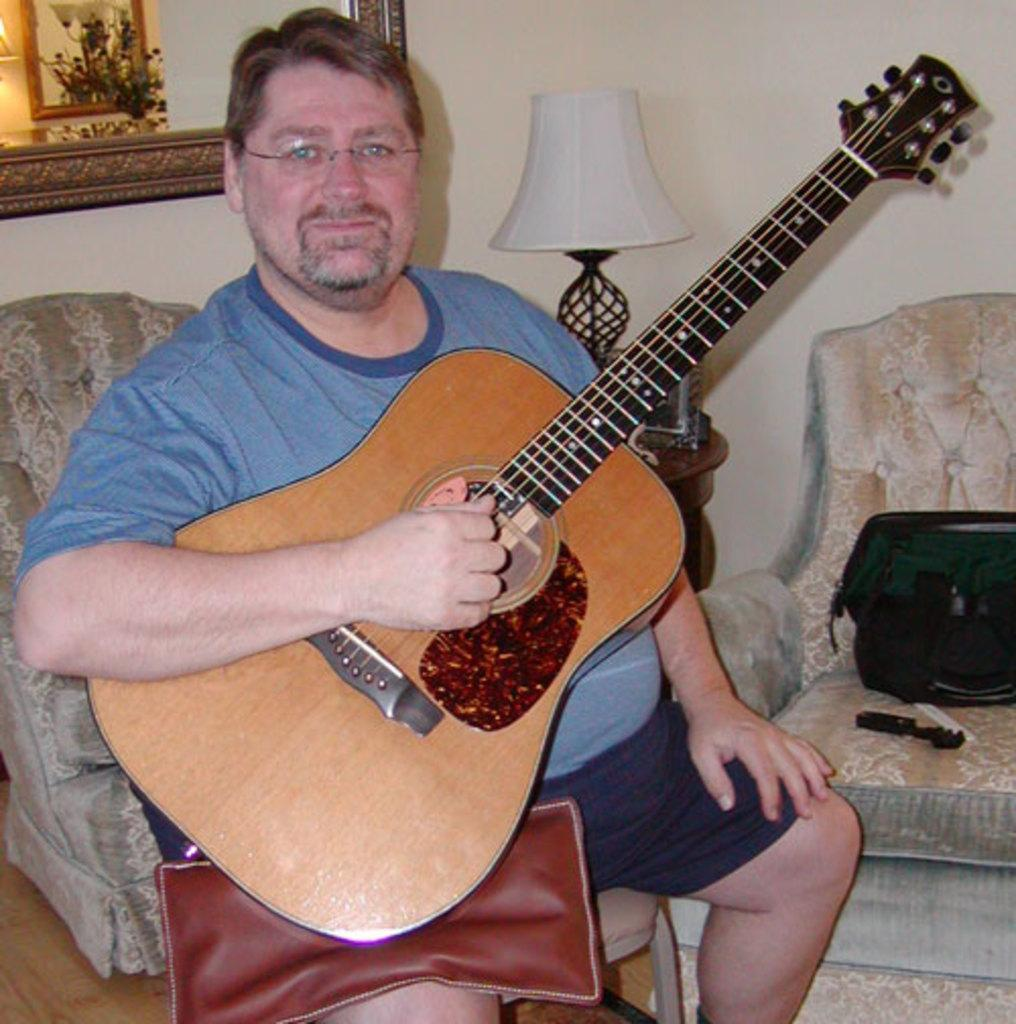What is the man in the image holding? The man is holding a guitar. What is the man's position in the image? The man is sitting. What can be seen in the background of the image? There is a lamp and a frame on a wall in the background of the image. How many clocks are hanging on the wall behind the man in the image? There are no clocks visible in the image; only a lamp and a frame on a wall are present in the background. 